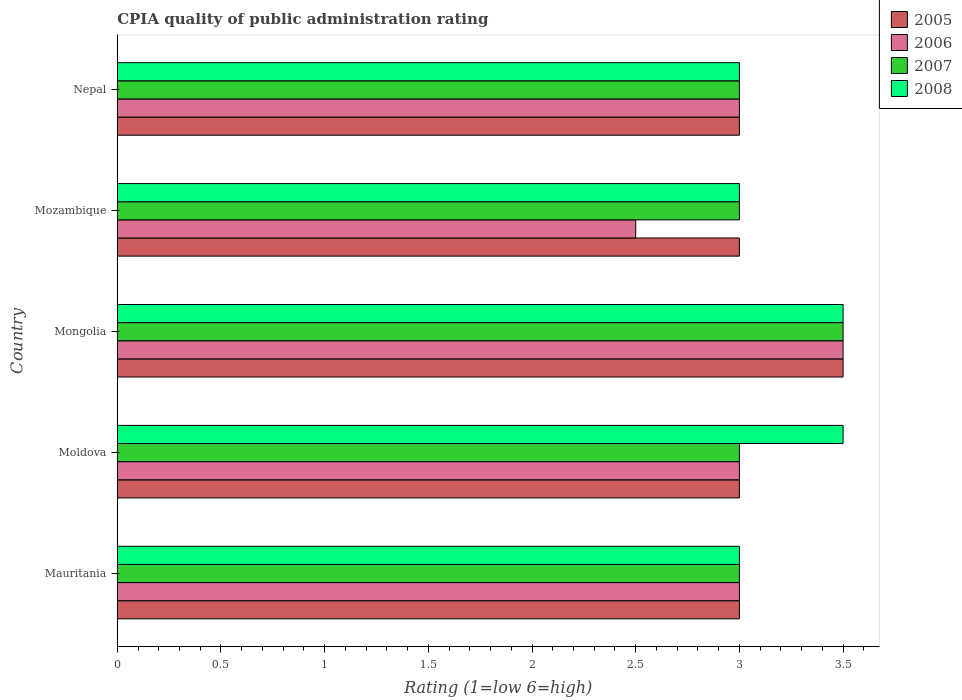How many different coloured bars are there?
Give a very brief answer. 4. How many groups of bars are there?
Provide a short and direct response. 5. How many bars are there on the 4th tick from the bottom?
Offer a terse response. 4. What is the label of the 5th group of bars from the top?
Keep it short and to the point. Mauritania. What is the CPIA rating in 2006 in Mongolia?
Keep it short and to the point. 3.5. Across all countries, what is the maximum CPIA rating in 2005?
Offer a very short reply. 3.5. In which country was the CPIA rating in 2005 maximum?
Provide a succinct answer. Mongolia. In which country was the CPIA rating in 2006 minimum?
Offer a terse response. Mozambique. What is the total CPIA rating in 2007 in the graph?
Make the answer very short. 15.5. What is the difference between the CPIA rating in 2008 in Mauritania and that in Mozambique?
Give a very brief answer. 0. What is the difference between the CPIA rating in 2008 and CPIA rating in 2007 in Moldova?
Your response must be concise. 0.5. What is the ratio of the CPIA rating in 2005 in Mozambique to that in Nepal?
Offer a terse response. 1. Is it the case that in every country, the sum of the CPIA rating in 2005 and CPIA rating in 2007 is greater than the sum of CPIA rating in 2006 and CPIA rating in 2008?
Ensure brevity in your answer.  No. What does the 2nd bar from the bottom in Moldova represents?
Ensure brevity in your answer.  2006. How many bars are there?
Your answer should be very brief. 20. Are all the bars in the graph horizontal?
Your answer should be compact. Yes. What is the difference between two consecutive major ticks on the X-axis?
Ensure brevity in your answer.  0.5. Are the values on the major ticks of X-axis written in scientific E-notation?
Your response must be concise. No. How are the legend labels stacked?
Make the answer very short. Vertical. What is the title of the graph?
Your answer should be very brief. CPIA quality of public administration rating. Does "2015" appear as one of the legend labels in the graph?
Keep it short and to the point. No. What is the Rating (1=low 6=high) in 2005 in Mauritania?
Provide a short and direct response. 3. What is the Rating (1=low 6=high) in 2006 in Moldova?
Keep it short and to the point. 3. What is the Rating (1=low 6=high) of 2008 in Moldova?
Give a very brief answer. 3.5. What is the Rating (1=low 6=high) in 2005 in Mongolia?
Offer a terse response. 3.5. What is the Rating (1=low 6=high) in 2007 in Mongolia?
Your answer should be very brief. 3.5. What is the Rating (1=low 6=high) of 2008 in Mozambique?
Make the answer very short. 3. What is the Rating (1=low 6=high) in 2007 in Nepal?
Your response must be concise. 3. Across all countries, what is the maximum Rating (1=low 6=high) of 2005?
Your answer should be very brief. 3.5. Across all countries, what is the minimum Rating (1=low 6=high) of 2005?
Provide a short and direct response. 3. Across all countries, what is the minimum Rating (1=low 6=high) in 2006?
Ensure brevity in your answer.  2.5. Across all countries, what is the minimum Rating (1=low 6=high) of 2007?
Provide a short and direct response. 3. What is the total Rating (1=low 6=high) in 2007 in the graph?
Your response must be concise. 15.5. What is the total Rating (1=low 6=high) of 2008 in the graph?
Offer a very short reply. 16. What is the difference between the Rating (1=low 6=high) of 2005 in Mauritania and that in Moldova?
Give a very brief answer. 0. What is the difference between the Rating (1=low 6=high) of 2008 in Mauritania and that in Moldova?
Your answer should be very brief. -0.5. What is the difference between the Rating (1=low 6=high) of 2005 in Mauritania and that in Mongolia?
Provide a short and direct response. -0.5. What is the difference between the Rating (1=low 6=high) in 2006 in Mauritania and that in Mongolia?
Provide a succinct answer. -0.5. What is the difference between the Rating (1=low 6=high) in 2007 in Mauritania and that in Mongolia?
Keep it short and to the point. -0.5. What is the difference between the Rating (1=low 6=high) of 2008 in Mauritania and that in Mongolia?
Keep it short and to the point. -0.5. What is the difference between the Rating (1=low 6=high) of 2008 in Mauritania and that in Mozambique?
Make the answer very short. 0. What is the difference between the Rating (1=low 6=high) in 2006 in Mauritania and that in Nepal?
Your answer should be very brief. 0. What is the difference between the Rating (1=low 6=high) of 2008 in Mauritania and that in Nepal?
Your response must be concise. 0. What is the difference between the Rating (1=low 6=high) of 2005 in Moldova and that in Mongolia?
Offer a terse response. -0.5. What is the difference between the Rating (1=low 6=high) of 2006 in Moldova and that in Mongolia?
Offer a very short reply. -0.5. What is the difference between the Rating (1=low 6=high) of 2007 in Moldova and that in Mongolia?
Offer a very short reply. -0.5. What is the difference between the Rating (1=low 6=high) in 2008 in Moldova and that in Mongolia?
Give a very brief answer. 0. What is the difference between the Rating (1=low 6=high) in 2007 in Moldova and that in Mozambique?
Your answer should be very brief. 0. What is the difference between the Rating (1=low 6=high) in 2005 in Moldova and that in Nepal?
Offer a very short reply. 0. What is the difference between the Rating (1=low 6=high) in 2006 in Moldova and that in Nepal?
Offer a terse response. 0. What is the difference between the Rating (1=low 6=high) of 2007 in Moldova and that in Nepal?
Your answer should be compact. 0. What is the difference between the Rating (1=low 6=high) in 2005 in Mongolia and that in Mozambique?
Give a very brief answer. 0.5. What is the difference between the Rating (1=low 6=high) of 2006 in Mongolia and that in Mozambique?
Your response must be concise. 1. What is the difference between the Rating (1=low 6=high) in 2007 in Mongolia and that in Nepal?
Ensure brevity in your answer.  0.5. What is the difference between the Rating (1=low 6=high) in 2006 in Mauritania and the Rating (1=low 6=high) in 2007 in Moldova?
Offer a very short reply. 0. What is the difference between the Rating (1=low 6=high) of 2006 in Mauritania and the Rating (1=low 6=high) of 2008 in Moldova?
Your answer should be very brief. -0.5. What is the difference between the Rating (1=low 6=high) of 2007 in Mauritania and the Rating (1=low 6=high) of 2008 in Moldova?
Offer a very short reply. -0.5. What is the difference between the Rating (1=low 6=high) in 2005 in Mauritania and the Rating (1=low 6=high) in 2007 in Mongolia?
Your answer should be very brief. -0.5. What is the difference between the Rating (1=low 6=high) of 2005 in Mauritania and the Rating (1=low 6=high) of 2008 in Mongolia?
Provide a succinct answer. -0.5. What is the difference between the Rating (1=low 6=high) in 2006 in Mauritania and the Rating (1=low 6=high) in 2007 in Mongolia?
Offer a terse response. -0.5. What is the difference between the Rating (1=low 6=high) in 2006 in Mauritania and the Rating (1=low 6=high) in 2008 in Mongolia?
Give a very brief answer. -0.5. What is the difference between the Rating (1=low 6=high) of 2007 in Mauritania and the Rating (1=low 6=high) of 2008 in Mongolia?
Make the answer very short. -0.5. What is the difference between the Rating (1=low 6=high) in 2005 in Mauritania and the Rating (1=low 6=high) in 2006 in Mozambique?
Offer a terse response. 0.5. What is the difference between the Rating (1=low 6=high) of 2005 in Mauritania and the Rating (1=low 6=high) of 2008 in Mozambique?
Your answer should be compact. 0. What is the difference between the Rating (1=low 6=high) of 2006 in Mauritania and the Rating (1=low 6=high) of 2007 in Mozambique?
Your answer should be very brief. 0. What is the difference between the Rating (1=low 6=high) in 2005 in Mauritania and the Rating (1=low 6=high) in 2007 in Nepal?
Your answer should be very brief. 0. What is the difference between the Rating (1=low 6=high) in 2005 in Mauritania and the Rating (1=low 6=high) in 2008 in Nepal?
Your answer should be very brief. 0. What is the difference between the Rating (1=low 6=high) in 2006 in Mauritania and the Rating (1=low 6=high) in 2007 in Nepal?
Make the answer very short. 0. What is the difference between the Rating (1=low 6=high) of 2006 in Mauritania and the Rating (1=low 6=high) of 2008 in Nepal?
Offer a very short reply. 0. What is the difference between the Rating (1=low 6=high) in 2007 in Mauritania and the Rating (1=low 6=high) in 2008 in Nepal?
Provide a succinct answer. 0. What is the difference between the Rating (1=low 6=high) in 2005 in Moldova and the Rating (1=low 6=high) in 2007 in Mongolia?
Ensure brevity in your answer.  -0.5. What is the difference between the Rating (1=low 6=high) in 2005 in Moldova and the Rating (1=low 6=high) in 2008 in Mongolia?
Your answer should be compact. -0.5. What is the difference between the Rating (1=low 6=high) of 2006 in Moldova and the Rating (1=low 6=high) of 2007 in Mongolia?
Provide a short and direct response. -0.5. What is the difference between the Rating (1=low 6=high) in 2006 in Moldova and the Rating (1=low 6=high) in 2008 in Mongolia?
Your answer should be compact. -0.5. What is the difference between the Rating (1=low 6=high) in 2005 in Moldova and the Rating (1=low 6=high) in 2008 in Mozambique?
Give a very brief answer. 0. What is the difference between the Rating (1=low 6=high) of 2006 in Moldova and the Rating (1=low 6=high) of 2007 in Mozambique?
Your answer should be compact. 0. What is the difference between the Rating (1=low 6=high) of 2005 in Moldova and the Rating (1=low 6=high) of 2006 in Nepal?
Your response must be concise. 0. What is the difference between the Rating (1=low 6=high) of 2005 in Moldova and the Rating (1=low 6=high) of 2008 in Nepal?
Give a very brief answer. 0. What is the difference between the Rating (1=low 6=high) in 2006 in Moldova and the Rating (1=low 6=high) in 2007 in Nepal?
Your answer should be very brief. 0. What is the difference between the Rating (1=low 6=high) of 2006 in Moldova and the Rating (1=low 6=high) of 2008 in Nepal?
Ensure brevity in your answer.  0. What is the difference between the Rating (1=low 6=high) in 2007 in Moldova and the Rating (1=low 6=high) in 2008 in Nepal?
Offer a terse response. 0. What is the difference between the Rating (1=low 6=high) of 2005 in Mongolia and the Rating (1=low 6=high) of 2007 in Mozambique?
Offer a terse response. 0.5. What is the difference between the Rating (1=low 6=high) of 2006 in Mongolia and the Rating (1=low 6=high) of 2008 in Mozambique?
Provide a succinct answer. 0.5. What is the difference between the Rating (1=low 6=high) in 2007 in Mongolia and the Rating (1=low 6=high) in 2008 in Mozambique?
Your answer should be compact. 0.5. What is the difference between the Rating (1=low 6=high) of 2006 in Mongolia and the Rating (1=low 6=high) of 2007 in Nepal?
Your answer should be compact. 0.5. What is the difference between the Rating (1=low 6=high) in 2007 in Mongolia and the Rating (1=low 6=high) in 2008 in Nepal?
Keep it short and to the point. 0.5. What is the difference between the Rating (1=low 6=high) of 2005 in Mozambique and the Rating (1=low 6=high) of 2007 in Nepal?
Offer a very short reply. 0. What is the difference between the Rating (1=low 6=high) of 2006 in Mozambique and the Rating (1=low 6=high) of 2008 in Nepal?
Provide a short and direct response. -0.5. What is the difference between the Rating (1=low 6=high) in 2007 in Mozambique and the Rating (1=low 6=high) in 2008 in Nepal?
Your response must be concise. 0. What is the average Rating (1=low 6=high) in 2005 per country?
Keep it short and to the point. 3.1. What is the average Rating (1=low 6=high) in 2006 per country?
Your answer should be very brief. 3. What is the average Rating (1=low 6=high) in 2007 per country?
Offer a very short reply. 3.1. What is the difference between the Rating (1=low 6=high) of 2005 and Rating (1=low 6=high) of 2006 in Mauritania?
Provide a short and direct response. 0. What is the difference between the Rating (1=low 6=high) in 2005 and Rating (1=low 6=high) in 2007 in Mauritania?
Offer a very short reply. 0. What is the difference between the Rating (1=low 6=high) of 2007 and Rating (1=low 6=high) of 2008 in Mauritania?
Your answer should be very brief. 0. What is the difference between the Rating (1=low 6=high) in 2005 and Rating (1=low 6=high) in 2007 in Moldova?
Offer a terse response. 0. What is the difference between the Rating (1=low 6=high) in 2005 and Rating (1=low 6=high) in 2008 in Moldova?
Offer a terse response. -0.5. What is the difference between the Rating (1=low 6=high) in 2005 and Rating (1=low 6=high) in 2007 in Mongolia?
Your answer should be compact. 0. What is the difference between the Rating (1=low 6=high) in 2005 and Rating (1=low 6=high) in 2008 in Mongolia?
Your response must be concise. 0. What is the difference between the Rating (1=low 6=high) in 2006 and Rating (1=low 6=high) in 2007 in Mongolia?
Your response must be concise. 0. What is the difference between the Rating (1=low 6=high) of 2006 and Rating (1=low 6=high) of 2008 in Mongolia?
Offer a very short reply. 0. What is the difference between the Rating (1=low 6=high) of 2007 and Rating (1=low 6=high) of 2008 in Mongolia?
Keep it short and to the point. 0. What is the difference between the Rating (1=low 6=high) of 2005 and Rating (1=low 6=high) of 2008 in Mozambique?
Your answer should be compact. 0. What is the difference between the Rating (1=low 6=high) in 2006 and Rating (1=low 6=high) in 2008 in Mozambique?
Your answer should be compact. -0.5. What is the difference between the Rating (1=low 6=high) in 2007 and Rating (1=low 6=high) in 2008 in Mozambique?
Offer a terse response. 0. What is the difference between the Rating (1=low 6=high) in 2005 and Rating (1=low 6=high) in 2007 in Nepal?
Provide a short and direct response. 0. What is the ratio of the Rating (1=low 6=high) in 2005 in Mauritania to that in Moldova?
Offer a terse response. 1. What is the ratio of the Rating (1=low 6=high) in 2006 in Mauritania to that in Moldova?
Make the answer very short. 1. What is the ratio of the Rating (1=low 6=high) of 2007 in Mauritania to that in Moldova?
Ensure brevity in your answer.  1. What is the ratio of the Rating (1=low 6=high) in 2005 in Mauritania to that in Mongolia?
Give a very brief answer. 0.86. What is the ratio of the Rating (1=low 6=high) of 2006 in Mauritania to that in Mongolia?
Keep it short and to the point. 0.86. What is the ratio of the Rating (1=low 6=high) in 2007 in Mauritania to that in Mongolia?
Offer a terse response. 0.86. What is the ratio of the Rating (1=low 6=high) in 2008 in Mauritania to that in Mongolia?
Keep it short and to the point. 0.86. What is the ratio of the Rating (1=low 6=high) in 2006 in Mauritania to that in Mozambique?
Offer a very short reply. 1.2. What is the ratio of the Rating (1=low 6=high) in 2007 in Mauritania to that in Mozambique?
Offer a very short reply. 1. What is the ratio of the Rating (1=low 6=high) of 2005 in Mauritania to that in Nepal?
Keep it short and to the point. 1. What is the ratio of the Rating (1=low 6=high) of 2006 in Mauritania to that in Nepal?
Provide a succinct answer. 1. What is the ratio of the Rating (1=low 6=high) of 2008 in Mauritania to that in Nepal?
Offer a very short reply. 1. What is the ratio of the Rating (1=low 6=high) in 2005 in Moldova to that in Mongolia?
Offer a terse response. 0.86. What is the ratio of the Rating (1=low 6=high) in 2005 in Moldova to that in Mozambique?
Your answer should be compact. 1. What is the ratio of the Rating (1=low 6=high) in 2007 in Moldova to that in Mozambique?
Ensure brevity in your answer.  1. What is the ratio of the Rating (1=low 6=high) in 2008 in Moldova to that in Mozambique?
Your answer should be very brief. 1.17. What is the ratio of the Rating (1=low 6=high) of 2005 in Moldova to that in Nepal?
Ensure brevity in your answer.  1. What is the ratio of the Rating (1=low 6=high) of 2006 in Moldova to that in Nepal?
Offer a terse response. 1. What is the ratio of the Rating (1=low 6=high) of 2007 in Moldova to that in Nepal?
Give a very brief answer. 1. What is the ratio of the Rating (1=low 6=high) in 2008 in Moldova to that in Nepal?
Provide a short and direct response. 1.17. What is the ratio of the Rating (1=low 6=high) of 2005 in Mongolia to that in Mozambique?
Provide a succinct answer. 1.17. What is the ratio of the Rating (1=low 6=high) in 2005 in Mongolia to that in Nepal?
Your answer should be very brief. 1.17. What is the ratio of the Rating (1=low 6=high) of 2006 in Mongolia to that in Nepal?
Offer a terse response. 1.17. What is the ratio of the Rating (1=low 6=high) of 2005 in Mozambique to that in Nepal?
Your response must be concise. 1. What is the ratio of the Rating (1=low 6=high) of 2006 in Mozambique to that in Nepal?
Provide a succinct answer. 0.83. What is the ratio of the Rating (1=low 6=high) in 2008 in Mozambique to that in Nepal?
Your answer should be compact. 1. What is the difference between the highest and the second highest Rating (1=low 6=high) in 2007?
Give a very brief answer. 0.5. What is the difference between the highest and the lowest Rating (1=low 6=high) in 2006?
Provide a short and direct response. 1. What is the difference between the highest and the lowest Rating (1=low 6=high) of 2007?
Make the answer very short. 0.5. What is the difference between the highest and the lowest Rating (1=low 6=high) of 2008?
Provide a succinct answer. 0.5. 